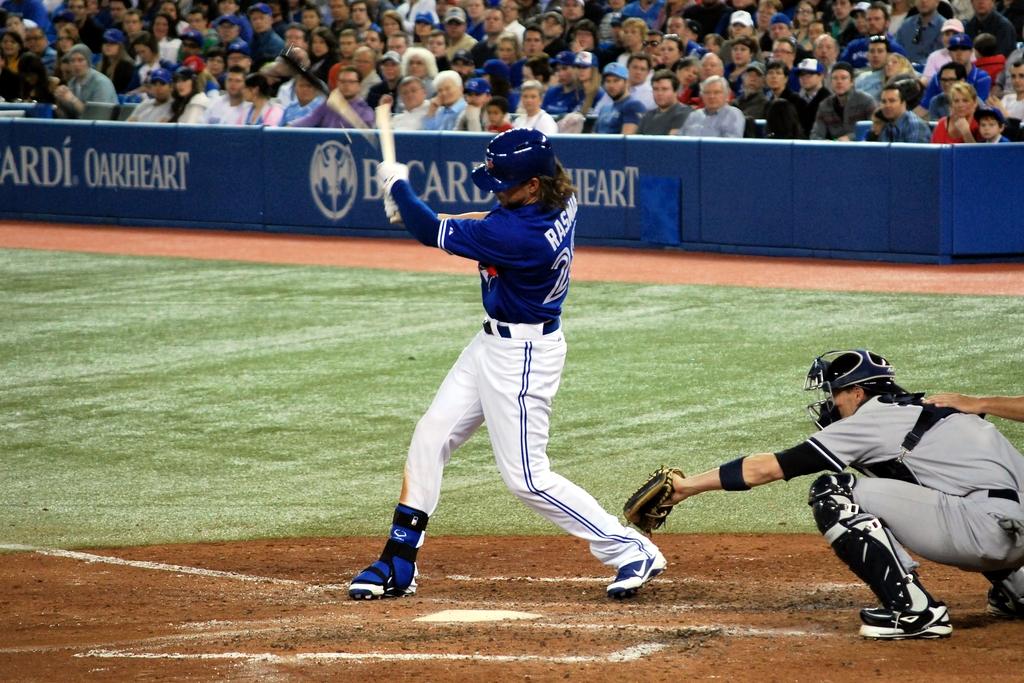What name is on the advertising board?
Your response must be concise. Bacardi. 